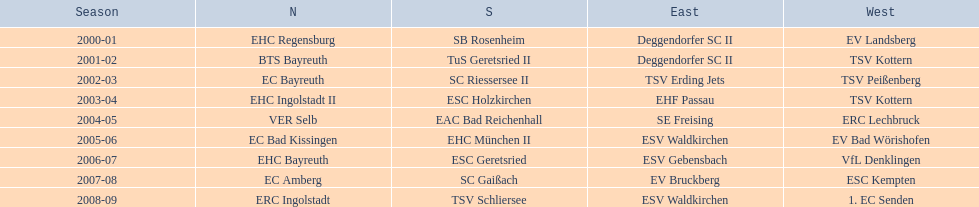Which teams won the north in their respective years? 2000-01, EHC Regensburg, BTS Bayreuth, EC Bayreuth, EHC Ingolstadt II, VER Selb, EC Bad Kissingen, EHC Bayreuth, EC Amberg, ERC Ingolstadt. Which one only won in 2000-01? EHC Regensburg. 